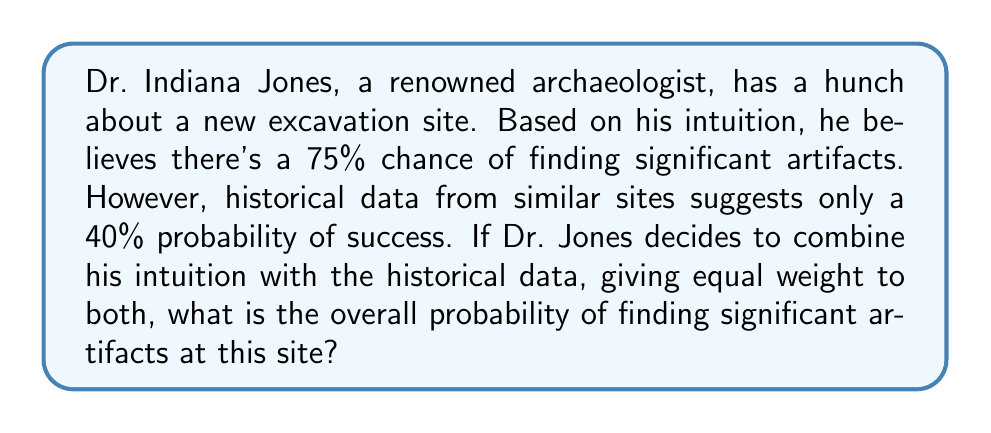Give your solution to this math problem. Let's approach this problem step-by-step, combining intuition with historical data:

1) Dr. Jones's intuition: $P_{intuition} = 0.75$ (75% chance)
2) Historical data: $P_{historical} = 0.40$ (40% chance)
3) Equal weight given to both: $w_{intuition} = w_{historical} = 0.5$

To calculate the overall probability, we'll use a weighted average:

$$P_{overall} = w_{intuition} \times P_{intuition} + w_{historical} \times P_{historical}$$

Substituting the values:

$$P_{overall} = 0.5 \times 0.75 + 0.5 \times 0.40$$

$$P_{overall} = 0.375 + 0.20$$

$$P_{overall} = 0.575$$

Therefore, the overall probability of finding significant artifacts at this site, combining Dr. Jones's intuition with historical data, is 0.575 or 57.5%.
Answer: $0.575$ or $57.5\%$ 